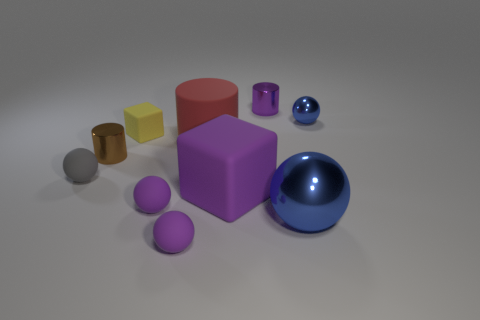Can you tell me what material the objects appear to be made of? The objects in the image appear to be rendered with different materials. Some have a matte surface suggesting a solid, possibly plastic or painted wood, while others are reflective and metallic, hinting at materials like polished steel or chrome. The varying materials create a diverse textural landscape. 